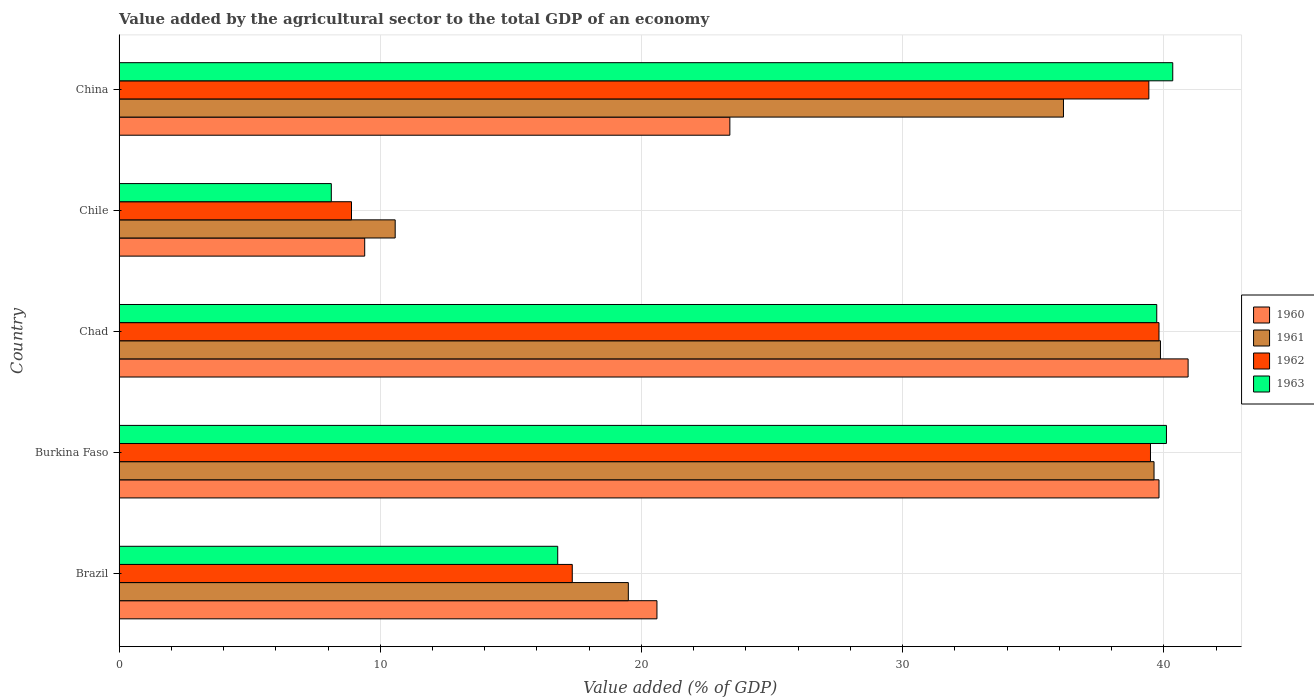How many groups of bars are there?
Provide a short and direct response. 5. Are the number of bars per tick equal to the number of legend labels?
Offer a terse response. Yes. How many bars are there on the 4th tick from the bottom?
Offer a terse response. 4. What is the value added by the agricultural sector to the total GDP in 1961 in Chad?
Provide a succinct answer. 39.87. Across all countries, what is the maximum value added by the agricultural sector to the total GDP in 1961?
Give a very brief answer. 39.87. Across all countries, what is the minimum value added by the agricultural sector to the total GDP in 1963?
Ensure brevity in your answer.  8.13. In which country was the value added by the agricultural sector to the total GDP in 1960 maximum?
Ensure brevity in your answer.  Chad. What is the total value added by the agricultural sector to the total GDP in 1962 in the graph?
Ensure brevity in your answer.  144.97. What is the difference between the value added by the agricultural sector to the total GDP in 1960 in Chad and that in China?
Provide a short and direct response. 17.54. What is the difference between the value added by the agricultural sector to the total GDP in 1961 in Brazil and the value added by the agricultural sector to the total GDP in 1960 in China?
Your answer should be very brief. -3.89. What is the average value added by the agricultural sector to the total GDP in 1963 per country?
Ensure brevity in your answer.  29.02. What is the difference between the value added by the agricultural sector to the total GDP in 1960 and value added by the agricultural sector to the total GDP in 1963 in Chad?
Provide a short and direct response. 1.2. In how many countries, is the value added by the agricultural sector to the total GDP in 1963 greater than 36 %?
Your answer should be very brief. 3. What is the ratio of the value added by the agricultural sector to the total GDP in 1963 in Brazil to that in Burkina Faso?
Ensure brevity in your answer.  0.42. Is the value added by the agricultural sector to the total GDP in 1960 in Burkina Faso less than that in Chile?
Offer a very short reply. No. Is the difference between the value added by the agricultural sector to the total GDP in 1960 in Burkina Faso and Chile greater than the difference between the value added by the agricultural sector to the total GDP in 1963 in Burkina Faso and Chile?
Your response must be concise. No. What is the difference between the highest and the second highest value added by the agricultural sector to the total GDP in 1963?
Offer a terse response. 0.24. What is the difference between the highest and the lowest value added by the agricultural sector to the total GDP in 1962?
Make the answer very short. 30.91. In how many countries, is the value added by the agricultural sector to the total GDP in 1963 greater than the average value added by the agricultural sector to the total GDP in 1963 taken over all countries?
Your response must be concise. 3. Is it the case that in every country, the sum of the value added by the agricultural sector to the total GDP in 1960 and value added by the agricultural sector to the total GDP in 1961 is greater than the sum of value added by the agricultural sector to the total GDP in 1962 and value added by the agricultural sector to the total GDP in 1963?
Offer a terse response. No. Is it the case that in every country, the sum of the value added by the agricultural sector to the total GDP in 1962 and value added by the agricultural sector to the total GDP in 1960 is greater than the value added by the agricultural sector to the total GDP in 1961?
Provide a succinct answer. Yes. How many bars are there?
Offer a very short reply. 20. How many countries are there in the graph?
Your answer should be compact. 5. How are the legend labels stacked?
Provide a succinct answer. Vertical. What is the title of the graph?
Make the answer very short. Value added by the agricultural sector to the total GDP of an economy. Does "1968" appear as one of the legend labels in the graph?
Keep it short and to the point. No. What is the label or title of the X-axis?
Your answer should be very brief. Value added (% of GDP). What is the label or title of the Y-axis?
Provide a succinct answer. Country. What is the Value added (% of GDP) of 1960 in Brazil?
Ensure brevity in your answer.  20.59. What is the Value added (% of GDP) of 1961 in Brazil?
Make the answer very short. 19.5. What is the Value added (% of GDP) of 1962 in Brazil?
Provide a succinct answer. 17.35. What is the Value added (% of GDP) in 1963 in Brazil?
Give a very brief answer. 16.79. What is the Value added (% of GDP) of 1960 in Burkina Faso?
Your answer should be very brief. 39.81. What is the Value added (% of GDP) of 1961 in Burkina Faso?
Provide a short and direct response. 39.62. What is the Value added (% of GDP) of 1962 in Burkina Faso?
Offer a very short reply. 39.49. What is the Value added (% of GDP) of 1963 in Burkina Faso?
Provide a short and direct response. 40.1. What is the Value added (% of GDP) of 1960 in Chad?
Provide a succinct answer. 40.93. What is the Value added (% of GDP) of 1961 in Chad?
Offer a terse response. 39.87. What is the Value added (% of GDP) of 1962 in Chad?
Offer a terse response. 39.81. What is the Value added (% of GDP) in 1963 in Chad?
Make the answer very short. 39.73. What is the Value added (% of GDP) of 1960 in Chile?
Provide a short and direct response. 9.4. What is the Value added (% of GDP) in 1961 in Chile?
Ensure brevity in your answer.  10.57. What is the Value added (% of GDP) in 1962 in Chile?
Ensure brevity in your answer.  8.9. What is the Value added (% of GDP) in 1963 in Chile?
Your response must be concise. 8.13. What is the Value added (% of GDP) in 1960 in China?
Your answer should be compact. 23.38. What is the Value added (% of GDP) in 1961 in China?
Offer a terse response. 36.16. What is the Value added (% of GDP) in 1962 in China?
Your answer should be compact. 39.42. What is the Value added (% of GDP) in 1963 in China?
Your answer should be very brief. 40.34. Across all countries, what is the maximum Value added (% of GDP) in 1960?
Offer a very short reply. 40.93. Across all countries, what is the maximum Value added (% of GDP) of 1961?
Your answer should be compact. 39.87. Across all countries, what is the maximum Value added (% of GDP) in 1962?
Provide a succinct answer. 39.81. Across all countries, what is the maximum Value added (% of GDP) in 1963?
Provide a short and direct response. 40.34. Across all countries, what is the minimum Value added (% of GDP) in 1960?
Keep it short and to the point. 9.4. Across all countries, what is the minimum Value added (% of GDP) of 1961?
Provide a short and direct response. 10.57. Across all countries, what is the minimum Value added (% of GDP) in 1962?
Your answer should be very brief. 8.9. Across all countries, what is the minimum Value added (% of GDP) of 1963?
Make the answer very short. 8.13. What is the total Value added (% of GDP) in 1960 in the graph?
Give a very brief answer. 134.12. What is the total Value added (% of GDP) in 1961 in the graph?
Your answer should be very brief. 145.72. What is the total Value added (% of GDP) in 1962 in the graph?
Provide a short and direct response. 144.97. What is the total Value added (% of GDP) of 1963 in the graph?
Keep it short and to the point. 145.08. What is the difference between the Value added (% of GDP) in 1960 in Brazil and that in Burkina Faso?
Offer a terse response. -19.22. What is the difference between the Value added (% of GDP) in 1961 in Brazil and that in Burkina Faso?
Your response must be concise. -20.13. What is the difference between the Value added (% of GDP) in 1962 in Brazil and that in Burkina Faso?
Ensure brevity in your answer.  -22.14. What is the difference between the Value added (% of GDP) in 1963 in Brazil and that in Burkina Faso?
Ensure brevity in your answer.  -23.3. What is the difference between the Value added (% of GDP) of 1960 in Brazil and that in Chad?
Make the answer very short. -20.33. What is the difference between the Value added (% of GDP) of 1961 in Brazil and that in Chad?
Your response must be concise. -20.37. What is the difference between the Value added (% of GDP) of 1962 in Brazil and that in Chad?
Provide a short and direct response. -22.46. What is the difference between the Value added (% of GDP) in 1963 in Brazil and that in Chad?
Your response must be concise. -22.93. What is the difference between the Value added (% of GDP) of 1960 in Brazil and that in Chile?
Make the answer very short. 11.19. What is the difference between the Value added (% of GDP) in 1961 in Brazil and that in Chile?
Provide a short and direct response. 8.93. What is the difference between the Value added (% of GDP) of 1962 in Brazil and that in Chile?
Make the answer very short. 8.45. What is the difference between the Value added (% of GDP) in 1963 in Brazil and that in Chile?
Your response must be concise. 8.67. What is the difference between the Value added (% of GDP) in 1960 in Brazil and that in China?
Provide a short and direct response. -2.79. What is the difference between the Value added (% of GDP) in 1961 in Brazil and that in China?
Provide a short and direct response. -16.66. What is the difference between the Value added (% of GDP) in 1962 in Brazil and that in China?
Give a very brief answer. -22.07. What is the difference between the Value added (% of GDP) of 1963 in Brazil and that in China?
Offer a very short reply. -23.55. What is the difference between the Value added (% of GDP) of 1960 in Burkina Faso and that in Chad?
Make the answer very short. -1.11. What is the difference between the Value added (% of GDP) in 1961 in Burkina Faso and that in Chad?
Offer a terse response. -0.25. What is the difference between the Value added (% of GDP) in 1962 in Burkina Faso and that in Chad?
Provide a short and direct response. -0.33. What is the difference between the Value added (% of GDP) of 1963 in Burkina Faso and that in Chad?
Give a very brief answer. 0.37. What is the difference between the Value added (% of GDP) in 1960 in Burkina Faso and that in Chile?
Ensure brevity in your answer.  30.41. What is the difference between the Value added (% of GDP) in 1961 in Burkina Faso and that in Chile?
Your answer should be very brief. 29.05. What is the difference between the Value added (% of GDP) in 1962 in Burkina Faso and that in Chile?
Your answer should be very brief. 30.59. What is the difference between the Value added (% of GDP) of 1963 in Burkina Faso and that in Chile?
Give a very brief answer. 31.97. What is the difference between the Value added (% of GDP) of 1960 in Burkina Faso and that in China?
Your answer should be very brief. 16.43. What is the difference between the Value added (% of GDP) of 1961 in Burkina Faso and that in China?
Provide a succinct answer. 3.47. What is the difference between the Value added (% of GDP) in 1962 in Burkina Faso and that in China?
Your response must be concise. 0.06. What is the difference between the Value added (% of GDP) in 1963 in Burkina Faso and that in China?
Give a very brief answer. -0.24. What is the difference between the Value added (% of GDP) in 1960 in Chad and that in Chile?
Provide a short and direct response. 31.52. What is the difference between the Value added (% of GDP) in 1961 in Chad and that in Chile?
Provide a short and direct response. 29.3. What is the difference between the Value added (% of GDP) in 1962 in Chad and that in Chile?
Provide a short and direct response. 30.91. What is the difference between the Value added (% of GDP) in 1963 in Chad and that in Chile?
Your answer should be compact. 31.6. What is the difference between the Value added (% of GDP) of 1960 in Chad and that in China?
Your response must be concise. 17.54. What is the difference between the Value added (% of GDP) of 1961 in Chad and that in China?
Give a very brief answer. 3.71. What is the difference between the Value added (% of GDP) in 1962 in Chad and that in China?
Keep it short and to the point. 0.39. What is the difference between the Value added (% of GDP) in 1963 in Chad and that in China?
Offer a terse response. -0.61. What is the difference between the Value added (% of GDP) in 1960 in Chile and that in China?
Offer a terse response. -13.98. What is the difference between the Value added (% of GDP) of 1961 in Chile and that in China?
Make the answer very short. -25.58. What is the difference between the Value added (% of GDP) in 1962 in Chile and that in China?
Your response must be concise. -30.52. What is the difference between the Value added (% of GDP) of 1963 in Chile and that in China?
Provide a short and direct response. -32.21. What is the difference between the Value added (% of GDP) in 1960 in Brazil and the Value added (% of GDP) in 1961 in Burkina Faso?
Ensure brevity in your answer.  -19.03. What is the difference between the Value added (% of GDP) of 1960 in Brazil and the Value added (% of GDP) of 1962 in Burkina Faso?
Offer a very short reply. -18.89. What is the difference between the Value added (% of GDP) in 1960 in Brazil and the Value added (% of GDP) in 1963 in Burkina Faso?
Provide a short and direct response. -19.51. What is the difference between the Value added (% of GDP) of 1961 in Brazil and the Value added (% of GDP) of 1962 in Burkina Faso?
Offer a very short reply. -19.99. What is the difference between the Value added (% of GDP) of 1961 in Brazil and the Value added (% of GDP) of 1963 in Burkina Faso?
Your answer should be compact. -20.6. What is the difference between the Value added (% of GDP) of 1962 in Brazil and the Value added (% of GDP) of 1963 in Burkina Faso?
Your answer should be compact. -22.75. What is the difference between the Value added (% of GDP) of 1960 in Brazil and the Value added (% of GDP) of 1961 in Chad?
Provide a short and direct response. -19.28. What is the difference between the Value added (% of GDP) of 1960 in Brazil and the Value added (% of GDP) of 1962 in Chad?
Provide a short and direct response. -19.22. What is the difference between the Value added (% of GDP) in 1960 in Brazil and the Value added (% of GDP) in 1963 in Chad?
Offer a very short reply. -19.13. What is the difference between the Value added (% of GDP) in 1961 in Brazil and the Value added (% of GDP) in 1962 in Chad?
Your response must be concise. -20.32. What is the difference between the Value added (% of GDP) of 1961 in Brazil and the Value added (% of GDP) of 1963 in Chad?
Give a very brief answer. -20.23. What is the difference between the Value added (% of GDP) of 1962 in Brazil and the Value added (% of GDP) of 1963 in Chad?
Make the answer very short. -22.38. What is the difference between the Value added (% of GDP) of 1960 in Brazil and the Value added (% of GDP) of 1961 in Chile?
Ensure brevity in your answer.  10.02. What is the difference between the Value added (% of GDP) in 1960 in Brazil and the Value added (% of GDP) in 1962 in Chile?
Your response must be concise. 11.69. What is the difference between the Value added (% of GDP) in 1960 in Brazil and the Value added (% of GDP) in 1963 in Chile?
Make the answer very short. 12.47. What is the difference between the Value added (% of GDP) in 1961 in Brazil and the Value added (% of GDP) in 1962 in Chile?
Offer a very short reply. 10.6. What is the difference between the Value added (% of GDP) of 1961 in Brazil and the Value added (% of GDP) of 1963 in Chile?
Ensure brevity in your answer.  11.37. What is the difference between the Value added (% of GDP) of 1962 in Brazil and the Value added (% of GDP) of 1963 in Chile?
Your response must be concise. 9.22. What is the difference between the Value added (% of GDP) in 1960 in Brazil and the Value added (% of GDP) in 1961 in China?
Offer a terse response. -15.56. What is the difference between the Value added (% of GDP) of 1960 in Brazil and the Value added (% of GDP) of 1962 in China?
Keep it short and to the point. -18.83. What is the difference between the Value added (% of GDP) in 1960 in Brazil and the Value added (% of GDP) in 1963 in China?
Provide a succinct answer. -19.75. What is the difference between the Value added (% of GDP) of 1961 in Brazil and the Value added (% of GDP) of 1962 in China?
Offer a terse response. -19.93. What is the difference between the Value added (% of GDP) of 1961 in Brazil and the Value added (% of GDP) of 1963 in China?
Ensure brevity in your answer.  -20.84. What is the difference between the Value added (% of GDP) in 1962 in Brazil and the Value added (% of GDP) in 1963 in China?
Your answer should be very brief. -22.99. What is the difference between the Value added (% of GDP) of 1960 in Burkina Faso and the Value added (% of GDP) of 1961 in Chad?
Offer a terse response. -0.06. What is the difference between the Value added (% of GDP) in 1960 in Burkina Faso and the Value added (% of GDP) in 1962 in Chad?
Provide a succinct answer. 0. What is the difference between the Value added (% of GDP) of 1960 in Burkina Faso and the Value added (% of GDP) of 1963 in Chad?
Provide a succinct answer. 0.09. What is the difference between the Value added (% of GDP) of 1961 in Burkina Faso and the Value added (% of GDP) of 1962 in Chad?
Your response must be concise. -0.19. What is the difference between the Value added (% of GDP) of 1961 in Burkina Faso and the Value added (% of GDP) of 1963 in Chad?
Your answer should be very brief. -0.1. What is the difference between the Value added (% of GDP) in 1962 in Burkina Faso and the Value added (% of GDP) in 1963 in Chad?
Offer a terse response. -0.24. What is the difference between the Value added (% of GDP) in 1960 in Burkina Faso and the Value added (% of GDP) in 1961 in Chile?
Provide a short and direct response. 29.24. What is the difference between the Value added (% of GDP) in 1960 in Burkina Faso and the Value added (% of GDP) in 1962 in Chile?
Offer a very short reply. 30.91. What is the difference between the Value added (% of GDP) of 1960 in Burkina Faso and the Value added (% of GDP) of 1963 in Chile?
Offer a very short reply. 31.69. What is the difference between the Value added (% of GDP) of 1961 in Burkina Faso and the Value added (% of GDP) of 1962 in Chile?
Your response must be concise. 30.72. What is the difference between the Value added (% of GDP) in 1961 in Burkina Faso and the Value added (% of GDP) in 1963 in Chile?
Ensure brevity in your answer.  31.5. What is the difference between the Value added (% of GDP) in 1962 in Burkina Faso and the Value added (% of GDP) in 1963 in Chile?
Offer a terse response. 31.36. What is the difference between the Value added (% of GDP) of 1960 in Burkina Faso and the Value added (% of GDP) of 1961 in China?
Give a very brief answer. 3.66. What is the difference between the Value added (% of GDP) in 1960 in Burkina Faso and the Value added (% of GDP) in 1962 in China?
Provide a succinct answer. 0.39. What is the difference between the Value added (% of GDP) in 1960 in Burkina Faso and the Value added (% of GDP) in 1963 in China?
Your answer should be compact. -0.53. What is the difference between the Value added (% of GDP) in 1961 in Burkina Faso and the Value added (% of GDP) in 1962 in China?
Ensure brevity in your answer.  0.2. What is the difference between the Value added (% of GDP) in 1961 in Burkina Faso and the Value added (% of GDP) in 1963 in China?
Make the answer very short. -0.72. What is the difference between the Value added (% of GDP) of 1962 in Burkina Faso and the Value added (% of GDP) of 1963 in China?
Keep it short and to the point. -0.85. What is the difference between the Value added (% of GDP) in 1960 in Chad and the Value added (% of GDP) in 1961 in Chile?
Keep it short and to the point. 30.36. What is the difference between the Value added (% of GDP) of 1960 in Chad and the Value added (% of GDP) of 1962 in Chile?
Provide a succinct answer. 32.03. What is the difference between the Value added (% of GDP) in 1960 in Chad and the Value added (% of GDP) in 1963 in Chile?
Provide a succinct answer. 32.8. What is the difference between the Value added (% of GDP) of 1961 in Chad and the Value added (% of GDP) of 1962 in Chile?
Keep it short and to the point. 30.97. What is the difference between the Value added (% of GDP) in 1961 in Chad and the Value added (% of GDP) in 1963 in Chile?
Ensure brevity in your answer.  31.74. What is the difference between the Value added (% of GDP) of 1962 in Chad and the Value added (% of GDP) of 1963 in Chile?
Make the answer very short. 31.69. What is the difference between the Value added (% of GDP) in 1960 in Chad and the Value added (% of GDP) in 1961 in China?
Give a very brief answer. 4.77. What is the difference between the Value added (% of GDP) of 1960 in Chad and the Value added (% of GDP) of 1962 in China?
Make the answer very short. 1.5. What is the difference between the Value added (% of GDP) of 1960 in Chad and the Value added (% of GDP) of 1963 in China?
Provide a short and direct response. 0.59. What is the difference between the Value added (% of GDP) in 1961 in Chad and the Value added (% of GDP) in 1962 in China?
Provide a succinct answer. 0.44. What is the difference between the Value added (% of GDP) in 1961 in Chad and the Value added (% of GDP) in 1963 in China?
Provide a short and direct response. -0.47. What is the difference between the Value added (% of GDP) in 1962 in Chad and the Value added (% of GDP) in 1963 in China?
Keep it short and to the point. -0.53. What is the difference between the Value added (% of GDP) of 1960 in Chile and the Value added (% of GDP) of 1961 in China?
Offer a very short reply. -26.75. What is the difference between the Value added (% of GDP) of 1960 in Chile and the Value added (% of GDP) of 1962 in China?
Provide a succinct answer. -30.02. What is the difference between the Value added (% of GDP) in 1960 in Chile and the Value added (% of GDP) in 1963 in China?
Provide a short and direct response. -30.93. What is the difference between the Value added (% of GDP) of 1961 in Chile and the Value added (% of GDP) of 1962 in China?
Your response must be concise. -28.85. What is the difference between the Value added (% of GDP) of 1961 in Chile and the Value added (% of GDP) of 1963 in China?
Offer a very short reply. -29.77. What is the difference between the Value added (% of GDP) of 1962 in Chile and the Value added (% of GDP) of 1963 in China?
Your response must be concise. -31.44. What is the average Value added (% of GDP) of 1960 per country?
Your answer should be compact. 26.82. What is the average Value added (% of GDP) in 1961 per country?
Provide a short and direct response. 29.14. What is the average Value added (% of GDP) in 1962 per country?
Your response must be concise. 28.99. What is the average Value added (% of GDP) in 1963 per country?
Make the answer very short. 29.02. What is the difference between the Value added (% of GDP) of 1960 and Value added (% of GDP) of 1961 in Brazil?
Provide a short and direct response. 1.1. What is the difference between the Value added (% of GDP) in 1960 and Value added (% of GDP) in 1962 in Brazil?
Your answer should be very brief. 3.24. What is the difference between the Value added (% of GDP) of 1960 and Value added (% of GDP) of 1963 in Brazil?
Give a very brief answer. 3.8. What is the difference between the Value added (% of GDP) in 1961 and Value added (% of GDP) in 1962 in Brazil?
Ensure brevity in your answer.  2.15. What is the difference between the Value added (% of GDP) of 1961 and Value added (% of GDP) of 1963 in Brazil?
Offer a terse response. 2.7. What is the difference between the Value added (% of GDP) of 1962 and Value added (% of GDP) of 1963 in Brazil?
Offer a terse response. 0.56. What is the difference between the Value added (% of GDP) of 1960 and Value added (% of GDP) of 1961 in Burkina Faso?
Make the answer very short. 0.19. What is the difference between the Value added (% of GDP) in 1960 and Value added (% of GDP) in 1962 in Burkina Faso?
Offer a terse response. 0.33. What is the difference between the Value added (% of GDP) of 1960 and Value added (% of GDP) of 1963 in Burkina Faso?
Keep it short and to the point. -0.29. What is the difference between the Value added (% of GDP) in 1961 and Value added (% of GDP) in 1962 in Burkina Faso?
Ensure brevity in your answer.  0.14. What is the difference between the Value added (% of GDP) of 1961 and Value added (% of GDP) of 1963 in Burkina Faso?
Provide a short and direct response. -0.48. What is the difference between the Value added (% of GDP) in 1962 and Value added (% of GDP) in 1963 in Burkina Faso?
Your answer should be compact. -0.61. What is the difference between the Value added (% of GDP) of 1960 and Value added (% of GDP) of 1961 in Chad?
Keep it short and to the point. 1.06. What is the difference between the Value added (% of GDP) in 1960 and Value added (% of GDP) in 1962 in Chad?
Keep it short and to the point. 1.11. What is the difference between the Value added (% of GDP) of 1960 and Value added (% of GDP) of 1963 in Chad?
Offer a very short reply. 1.2. What is the difference between the Value added (% of GDP) of 1961 and Value added (% of GDP) of 1962 in Chad?
Make the answer very short. 0.06. What is the difference between the Value added (% of GDP) of 1961 and Value added (% of GDP) of 1963 in Chad?
Your answer should be very brief. 0.14. What is the difference between the Value added (% of GDP) in 1962 and Value added (% of GDP) in 1963 in Chad?
Your answer should be very brief. 0.09. What is the difference between the Value added (% of GDP) in 1960 and Value added (% of GDP) in 1961 in Chile?
Provide a short and direct response. -1.17. What is the difference between the Value added (% of GDP) in 1960 and Value added (% of GDP) in 1962 in Chile?
Offer a terse response. 0.51. What is the difference between the Value added (% of GDP) of 1960 and Value added (% of GDP) of 1963 in Chile?
Provide a short and direct response. 1.28. What is the difference between the Value added (% of GDP) of 1961 and Value added (% of GDP) of 1962 in Chile?
Your response must be concise. 1.67. What is the difference between the Value added (% of GDP) of 1961 and Value added (% of GDP) of 1963 in Chile?
Keep it short and to the point. 2.45. What is the difference between the Value added (% of GDP) of 1962 and Value added (% of GDP) of 1963 in Chile?
Provide a short and direct response. 0.77. What is the difference between the Value added (% of GDP) in 1960 and Value added (% of GDP) in 1961 in China?
Give a very brief answer. -12.77. What is the difference between the Value added (% of GDP) of 1960 and Value added (% of GDP) of 1962 in China?
Keep it short and to the point. -16.04. What is the difference between the Value added (% of GDP) in 1960 and Value added (% of GDP) in 1963 in China?
Your answer should be very brief. -16.96. What is the difference between the Value added (% of GDP) of 1961 and Value added (% of GDP) of 1962 in China?
Provide a succinct answer. -3.27. What is the difference between the Value added (% of GDP) of 1961 and Value added (% of GDP) of 1963 in China?
Your answer should be compact. -4.18. What is the difference between the Value added (% of GDP) in 1962 and Value added (% of GDP) in 1963 in China?
Your answer should be compact. -0.91. What is the ratio of the Value added (% of GDP) of 1960 in Brazil to that in Burkina Faso?
Ensure brevity in your answer.  0.52. What is the ratio of the Value added (% of GDP) of 1961 in Brazil to that in Burkina Faso?
Your answer should be compact. 0.49. What is the ratio of the Value added (% of GDP) in 1962 in Brazil to that in Burkina Faso?
Provide a short and direct response. 0.44. What is the ratio of the Value added (% of GDP) of 1963 in Brazil to that in Burkina Faso?
Provide a succinct answer. 0.42. What is the ratio of the Value added (% of GDP) of 1960 in Brazil to that in Chad?
Provide a succinct answer. 0.5. What is the ratio of the Value added (% of GDP) in 1961 in Brazil to that in Chad?
Ensure brevity in your answer.  0.49. What is the ratio of the Value added (% of GDP) of 1962 in Brazil to that in Chad?
Keep it short and to the point. 0.44. What is the ratio of the Value added (% of GDP) of 1963 in Brazil to that in Chad?
Offer a very short reply. 0.42. What is the ratio of the Value added (% of GDP) in 1960 in Brazil to that in Chile?
Give a very brief answer. 2.19. What is the ratio of the Value added (% of GDP) of 1961 in Brazil to that in Chile?
Offer a very short reply. 1.84. What is the ratio of the Value added (% of GDP) of 1962 in Brazil to that in Chile?
Provide a short and direct response. 1.95. What is the ratio of the Value added (% of GDP) of 1963 in Brazil to that in Chile?
Your response must be concise. 2.07. What is the ratio of the Value added (% of GDP) of 1960 in Brazil to that in China?
Your response must be concise. 0.88. What is the ratio of the Value added (% of GDP) in 1961 in Brazil to that in China?
Your response must be concise. 0.54. What is the ratio of the Value added (% of GDP) of 1962 in Brazil to that in China?
Make the answer very short. 0.44. What is the ratio of the Value added (% of GDP) of 1963 in Brazil to that in China?
Offer a very short reply. 0.42. What is the ratio of the Value added (% of GDP) of 1960 in Burkina Faso to that in Chad?
Your answer should be compact. 0.97. What is the ratio of the Value added (% of GDP) in 1963 in Burkina Faso to that in Chad?
Provide a succinct answer. 1.01. What is the ratio of the Value added (% of GDP) in 1960 in Burkina Faso to that in Chile?
Your response must be concise. 4.23. What is the ratio of the Value added (% of GDP) of 1961 in Burkina Faso to that in Chile?
Offer a very short reply. 3.75. What is the ratio of the Value added (% of GDP) in 1962 in Burkina Faso to that in Chile?
Make the answer very short. 4.44. What is the ratio of the Value added (% of GDP) in 1963 in Burkina Faso to that in Chile?
Your response must be concise. 4.93. What is the ratio of the Value added (% of GDP) of 1960 in Burkina Faso to that in China?
Provide a succinct answer. 1.7. What is the ratio of the Value added (% of GDP) of 1961 in Burkina Faso to that in China?
Provide a short and direct response. 1.1. What is the ratio of the Value added (% of GDP) in 1960 in Chad to that in Chile?
Provide a short and direct response. 4.35. What is the ratio of the Value added (% of GDP) of 1961 in Chad to that in Chile?
Give a very brief answer. 3.77. What is the ratio of the Value added (% of GDP) of 1962 in Chad to that in Chile?
Ensure brevity in your answer.  4.47. What is the ratio of the Value added (% of GDP) of 1963 in Chad to that in Chile?
Your answer should be compact. 4.89. What is the ratio of the Value added (% of GDP) of 1960 in Chad to that in China?
Your answer should be very brief. 1.75. What is the ratio of the Value added (% of GDP) in 1961 in Chad to that in China?
Make the answer very short. 1.1. What is the ratio of the Value added (% of GDP) in 1962 in Chad to that in China?
Your answer should be compact. 1.01. What is the ratio of the Value added (% of GDP) in 1960 in Chile to that in China?
Your response must be concise. 0.4. What is the ratio of the Value added (% of GDP) of 1961 in Chile to that in China?
Keep it short and to the point. 0.29. What is the ratio of the Value added (% of GDP) in 1962 in Chile to that in China?
Make the answer very short. 0.23. What is the ratio of the Value added (% of GDP) in 1963 in Chile to that in China?
Your answer should be compact. 0.2. What is the difference between the highest and the second highest Value added (% of GDP) of 1960?
Offer a very short reply. 1.11. What is the difference between the highest and the second highest Value added (% of GDP) of 1961?
Keep it short and to the point. 0.25. What is the difference between the highest and the second highest Value added (% of GDP) in 1962?
Your answer should be very brief. 0.33. What is the difference between the highest and the second highest Value added (% of GDP) of 1963?
Provide a short and direct response. 0.24. What is the difference between the highest and the lowest Value added (% of GDP) in 1960?
Your response must be concise. 31.52. What is the difference between the highest and the lowest Value added (% of GDP) in 1961?
Your answer should be compact. 29.3. What is the difference between the highest and the lowest Value added (% of GDP) of 1962?
Provide a short and direct response. 30.91. What is the difference between the highest and the lowest Value added (% of GDP) in 1963?
Offer a terse response. 32.21. 